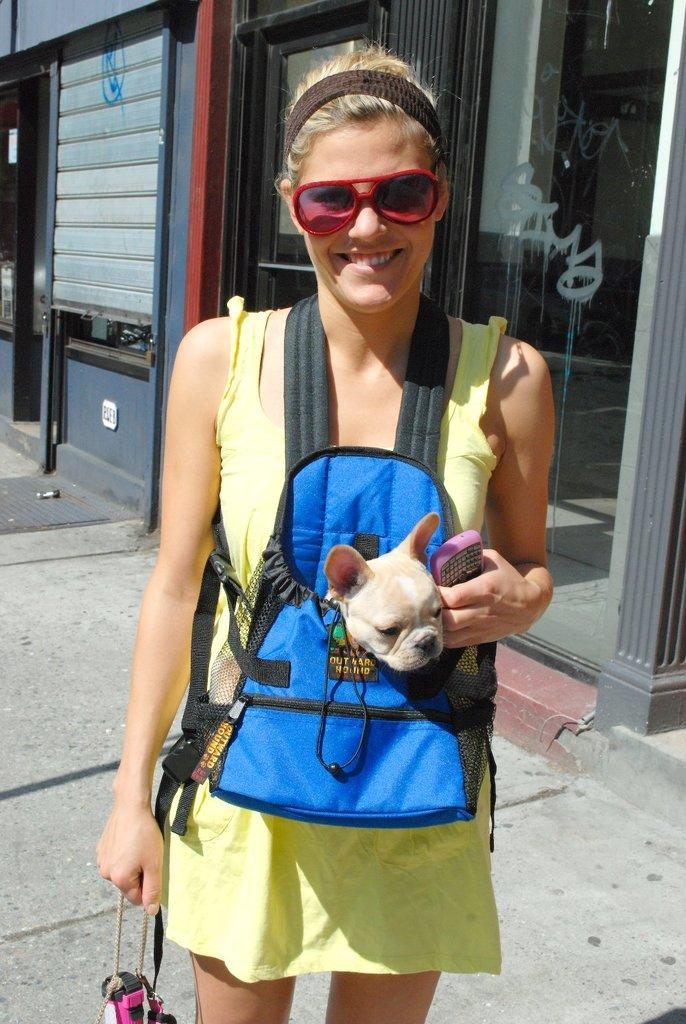Who is present in the image? There is a woman in the image. What is the woman doing in the image? The woman is standing on the floor and smiling. What is the woman holding in the image? The woman is holding a puppy in a pouch. What can be seen in the background of the image? There are glasses and windows in the background of the image. What type of crime is being committed in the image? There is no crime being committed in the image; it features a woman holding a puppy and smiling. What is the woman's desire in the image? The image does not provide information about the woman's desires or intentions. 